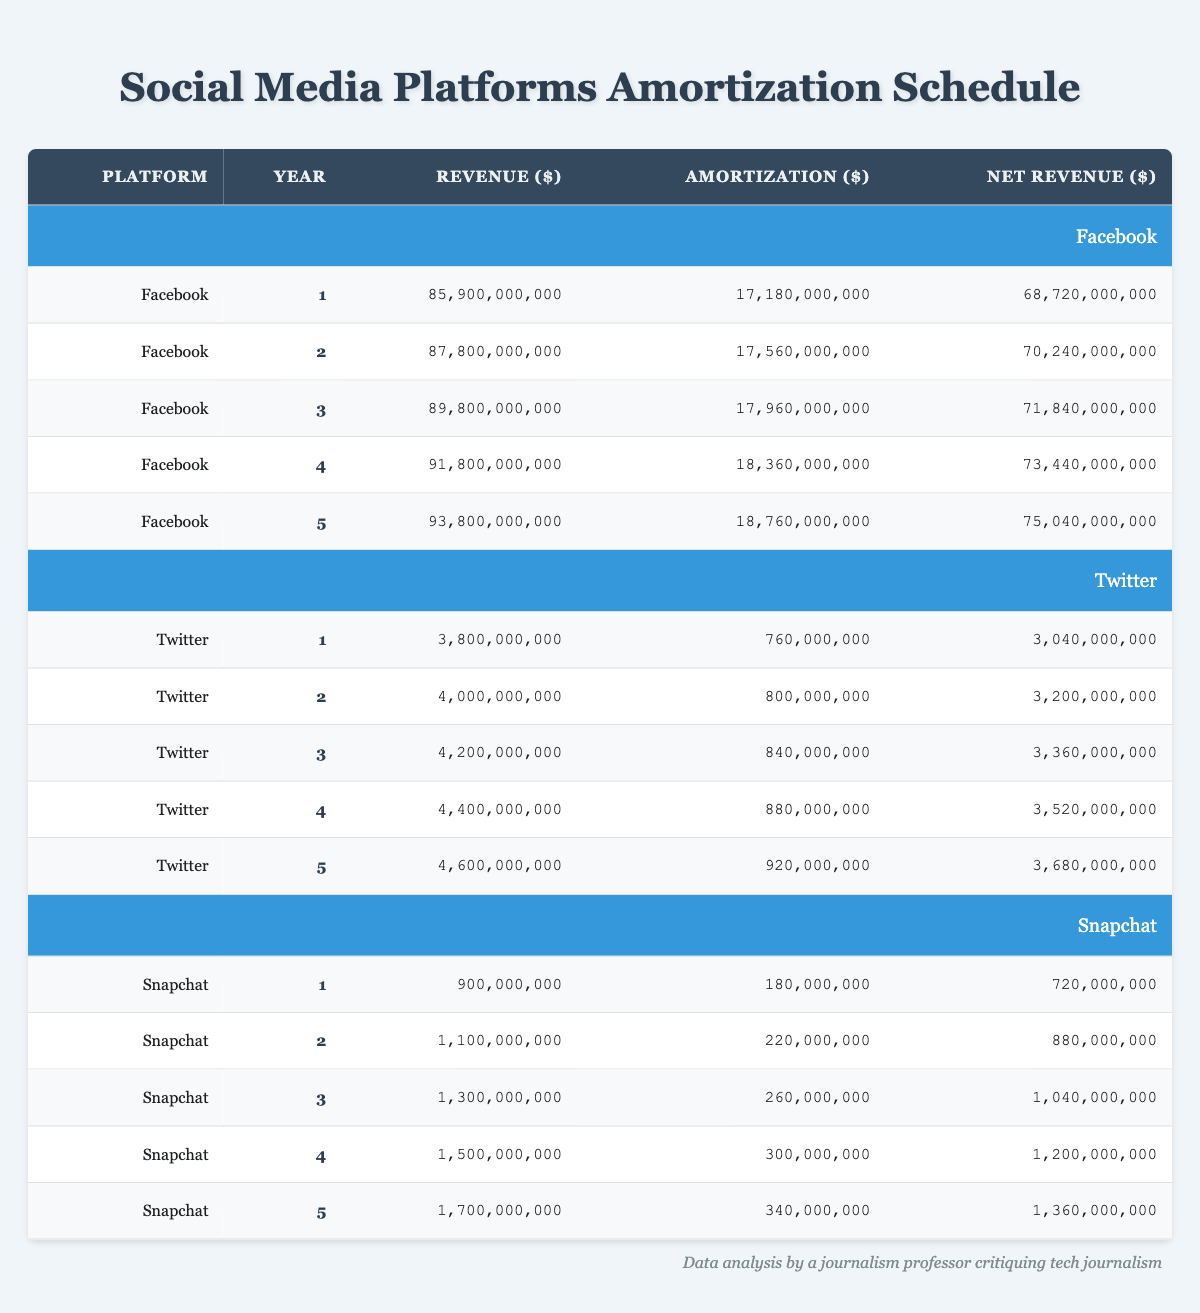What is the total revenue generated by Facebook in year 3? The revenue for Facebook in year 3 is directly listed in the table as 89,800,000,000.
Answer: 89,800,000,000 What was the net revenue for Twitter in year 5? The net revenue for Twitter in year 5 can be found in the table as 3,680,000,000.
Answer: 3,680,000,000 How much total amortization did Snapchat incur over the five years? To find the total amortization for Snapchat, we sum the amortization values for each year: 180,000,000 + 220,000,000 + 260,000,000 + 300,000,000 + 340,000,000 = 1,300,000,000.
Answer: 1,300,000,000 Did Facebook's net revenue increase every year? By comparing the net revenue values for each year, we see 68,720,000,000, 70,240,000,000, 71,840,000,000, 73,440,000,000, and 75,040,000,000, which shows a consistent increase each year.
Answer: Yes What is the average net revenue for Snapchat over the five years? The net revenues for Snapchat are: 720,000,000, 880,000,000, 1,040,000,000, 1,200,000,000, and 1,360,000,000. The sum is 720,000,000 + 880,000,000 + 1,040,000,000 + 1,200,000,000 + 1,360,000,000 = 5,200,000,000. Dividing by 5 gives an average of 5,200,000,000 / 5 = 1,040,000,000.
Answer: 1,040,000,000 What was the difference in amortization between Twitter's year 1 and year 4? Twitter's amortization in year 1 is 760,000,000 and in year 4 is 880,000,000. The difference is 880,000,000 - 760,000,000 = 120,000,000.
Answer: 120,000,000 What was the highest annual revenue among these platforms in year 4? Facebook's revenue in year 4 is 91,800,000,000, Twitter's revenue is 4,400,000,000, and Snapchat's revenue is 1,500,000,000. The highest among these is Facebook's 91,800,000,000.
Answer: 91,800,000,000 What is the percentage increase in net revenue for Facebook from year 1 to year 5? Facebook's net revenue in year 1 is 68,720,000,000 and in year 5 it is 75,040,000,000. The difference is 75,040,000,000 - 68,720,000,000 = 6,320,000,000. The percentage increase is (6,320,000,000 / 68,720,000,000) * 100 = approximately 9.2%.
Answer: 9.2% 